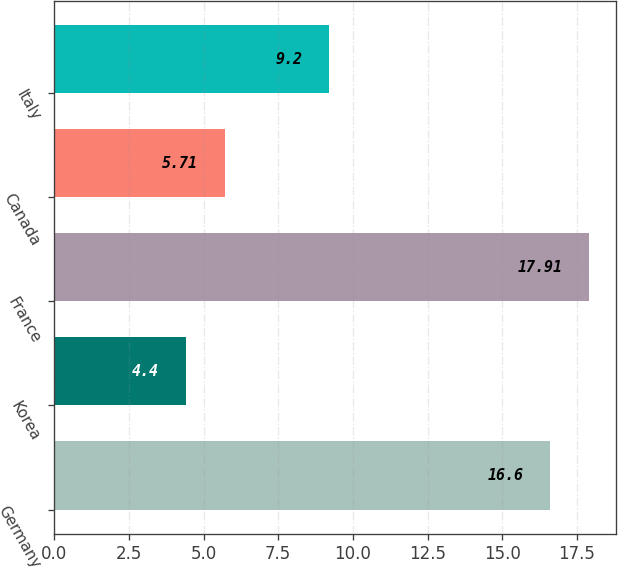Convert chart. <chart><loc_0><loc_0><loc_500><loc_500><bar_chart><fcel>Germany<fcel>Korea<fcel>France<fcel>Canada<fcel>Italy<nl><fcel>16.6<fcel>4.4<fcel>17.91<fcel>5.71<fcel>9.2<nl></chart> 